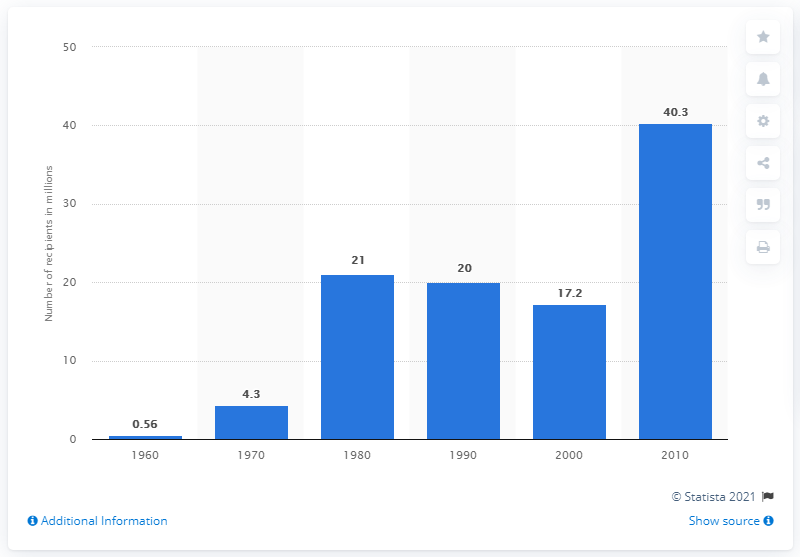Outline some significant characteristics in this image. In 2010, approximately 40.3 million Americans received benefits through the Supplemental Nutrition Assistance Program (SNAP). 